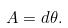<formula> <loc_0><loc_0><loc_500><loc_500>A = d \theta .</formula> 